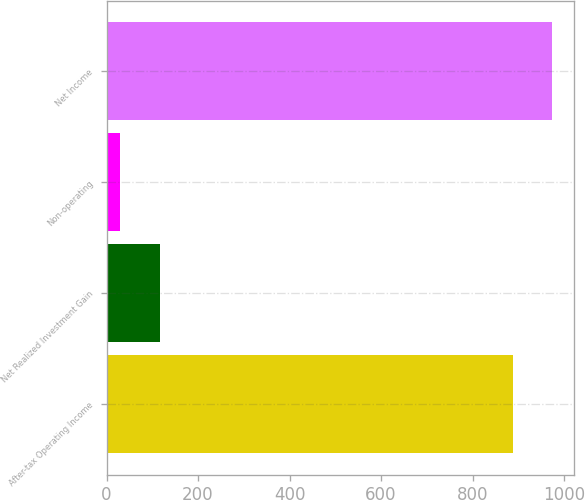<chart> <loc_0><loc_0><loc_500><loc_500><bar_chart><fcel>After-tax Operating Income<fcel>Net Realized Investment Gain<fcel>Non-operating<fcel>Net Income<nl><fcel>887.5<fcel>116.62<fcel>30.2<fcel>973.92<nl></chart> 